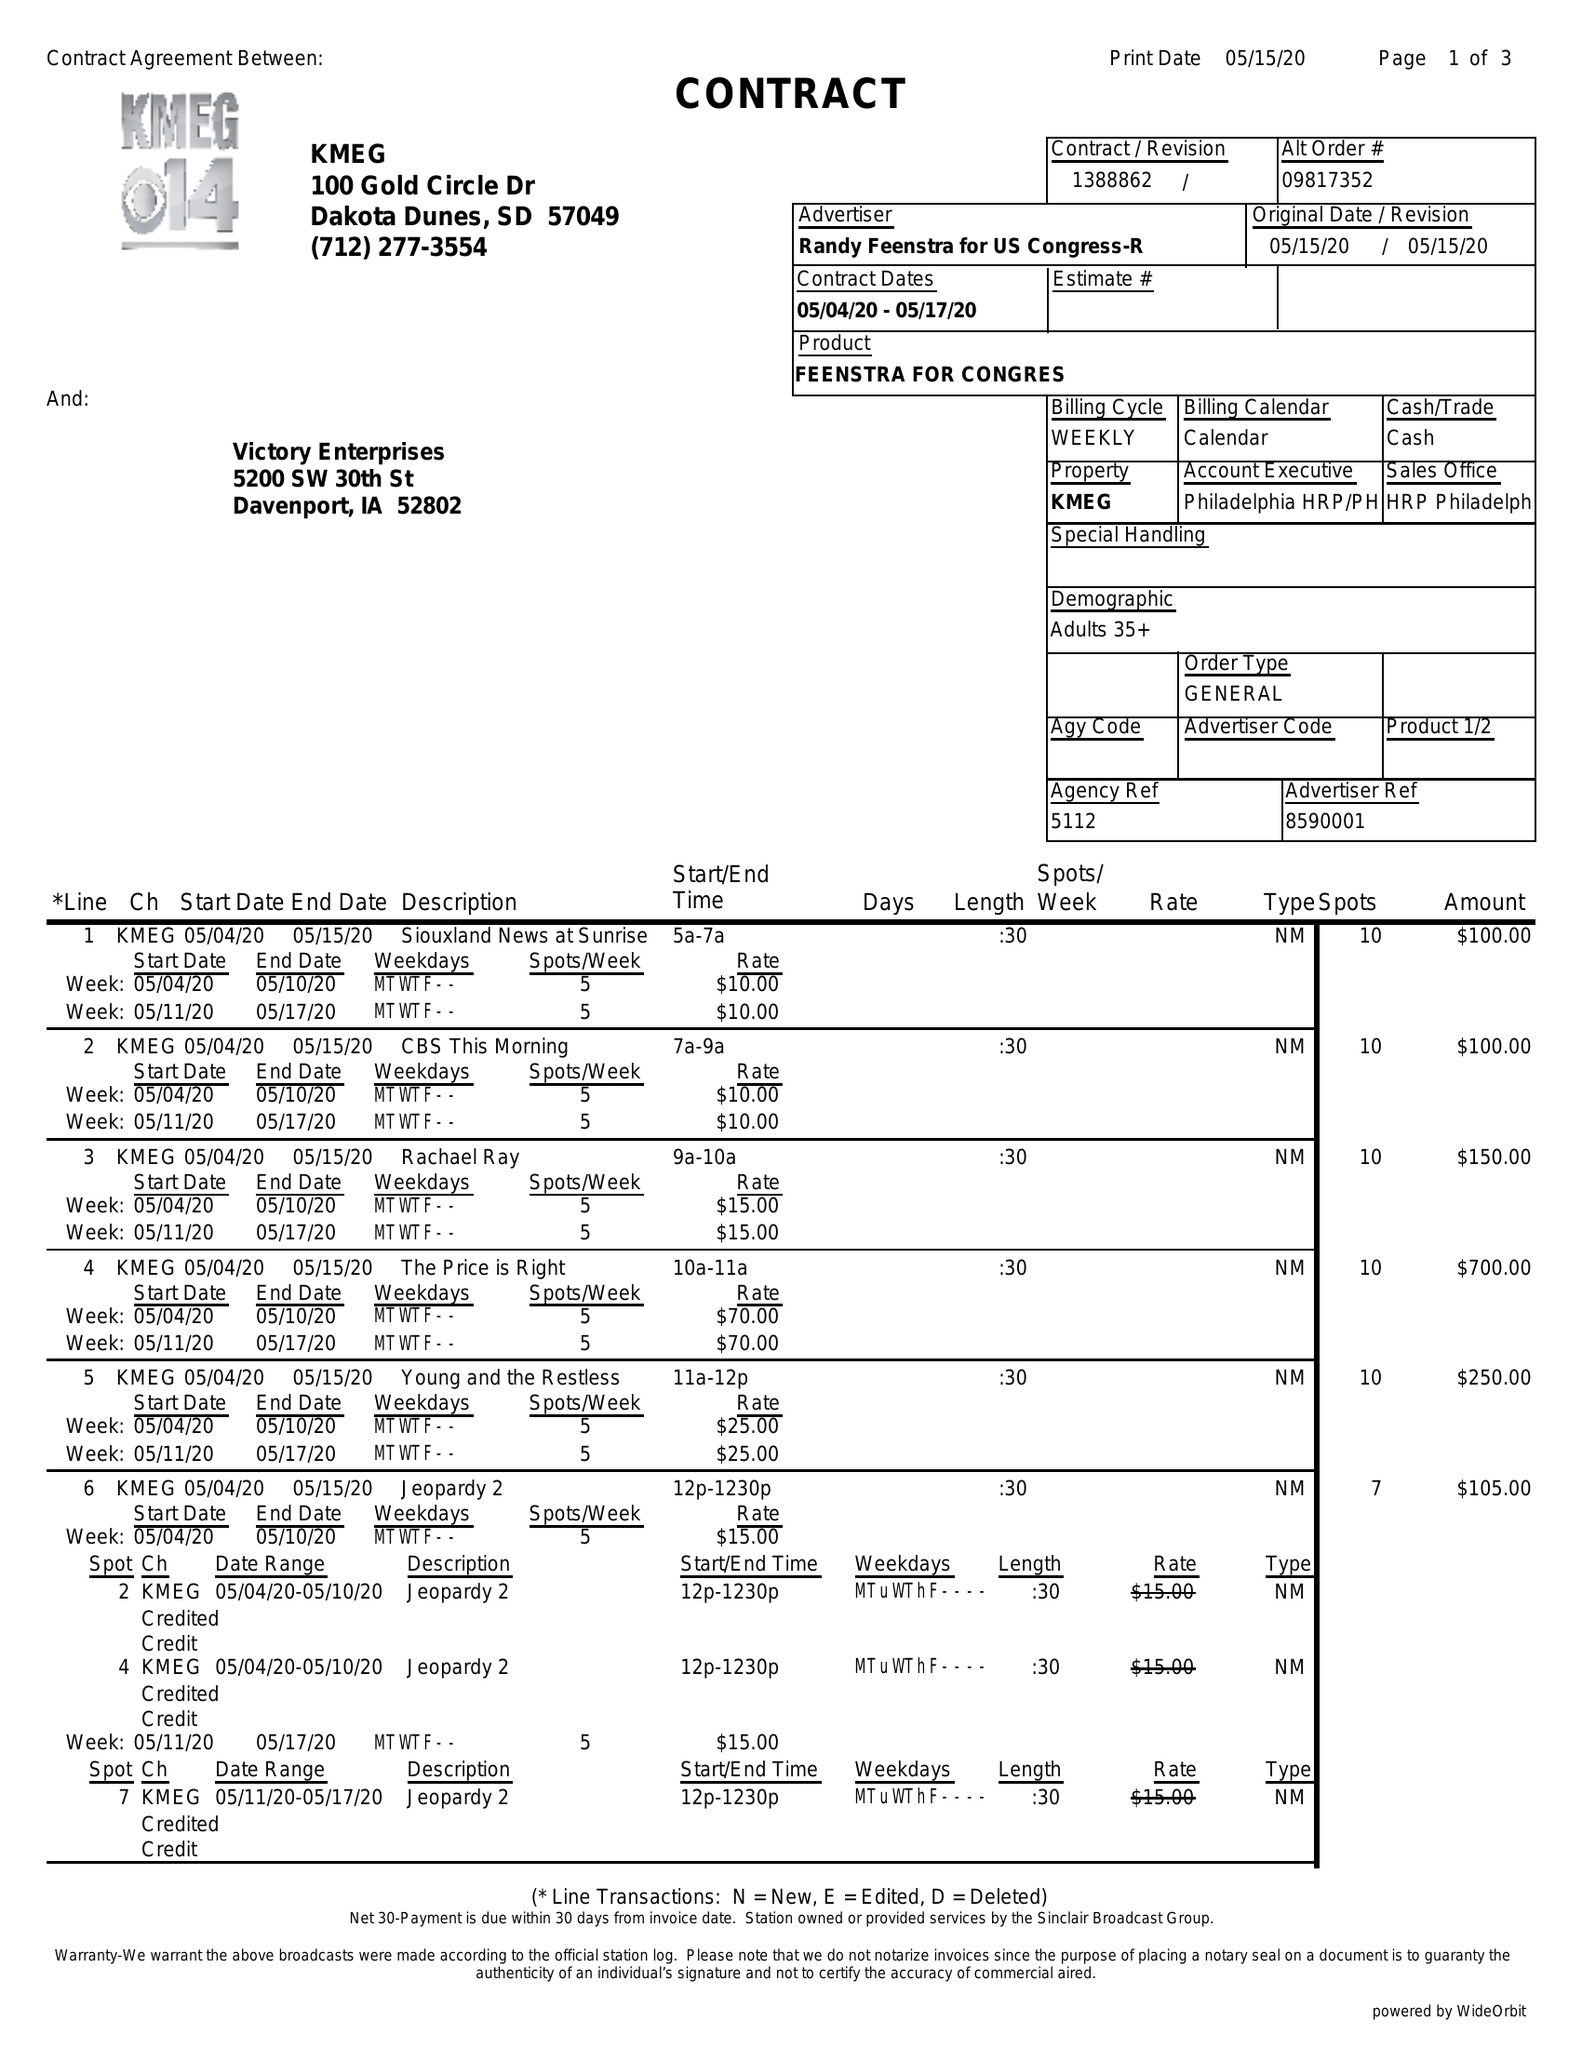What is the value for the flight_to?
Answer the question using a single word or phrase. 05/17/20 